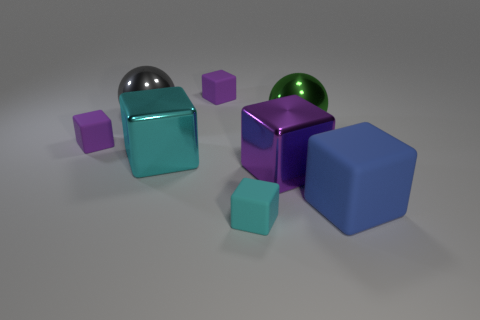Subtract all purple blocks. How many were subtracted if there are1purple blocks left? 2 Subtract all large matte cubes. How many cubes are left? 5 Subtract 5 blocks. How many blocks are left? 1 Add 1 small rubber blocks. How many objects exist? 9 Subtract all purple blocks. How many blocks are left? 3 Subtract all yellow cubes. Subtract all green spheres. How many cubes are left? 6 Subtract all gray balls. How many yellow blocks are left? 0 Subtract all blue metallic cylinders. Subtract all large green metal spheres. How many objects are left? 7 Add 2 big purple objects. How many big purple objects are left? 3 Add 7 cyan matte things. How many cyan matte things exist? 8 